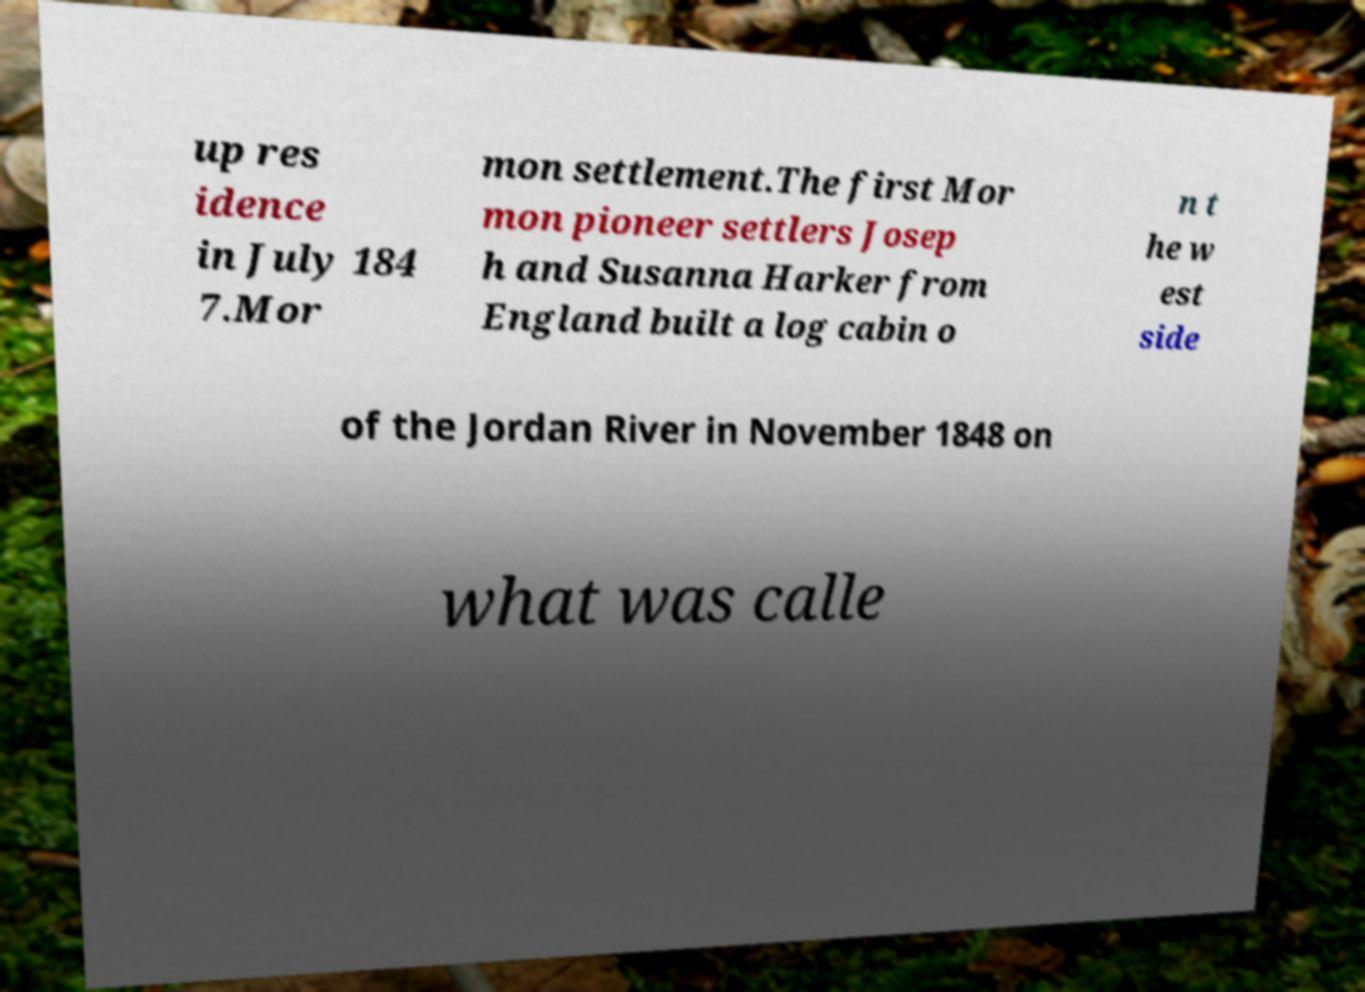What messages or text are displayed in this image? I need them in a readable, typed format. up res idence in July 184 7.Mor mon settlement.The first Mor mon pioneer settlers Josep h and Susanna Harker from England built a log cabin o n t he w est side of the Jordan River in November 1848 on what was calle 